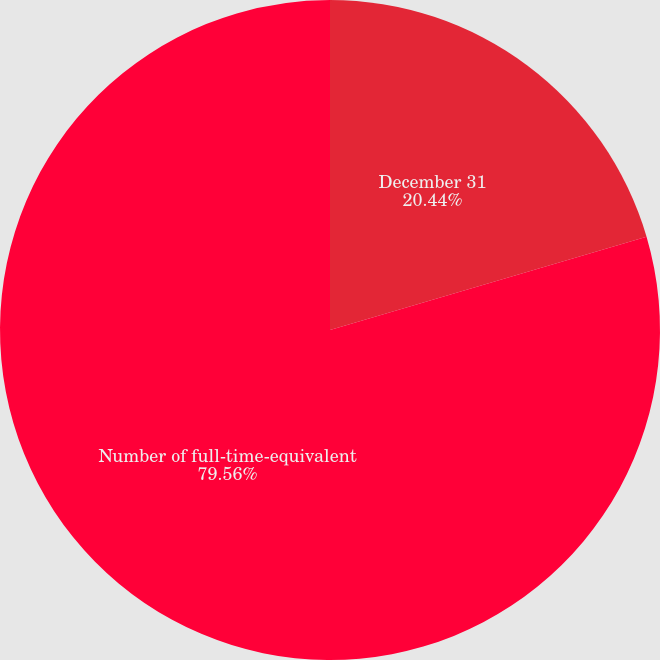Convert chart. <chart><loc_0><loc_0><loc_500><loc_500><pie_chart><fcel>December 31<fcel>Number of full-time-equivalent<nl><fcel>20.44%<fcel>79.56%<nl></chart> 